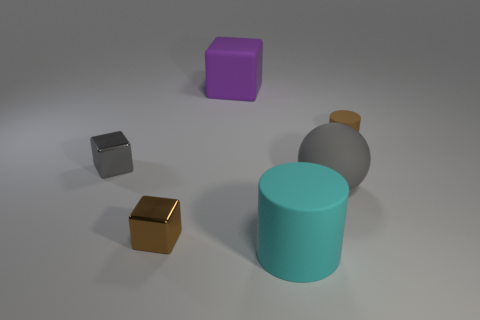What colors are present in the objects shown? The objects exhibit various colors including cyan, purple, brown, grey, and a darker shade that might be a dark grey or black. 